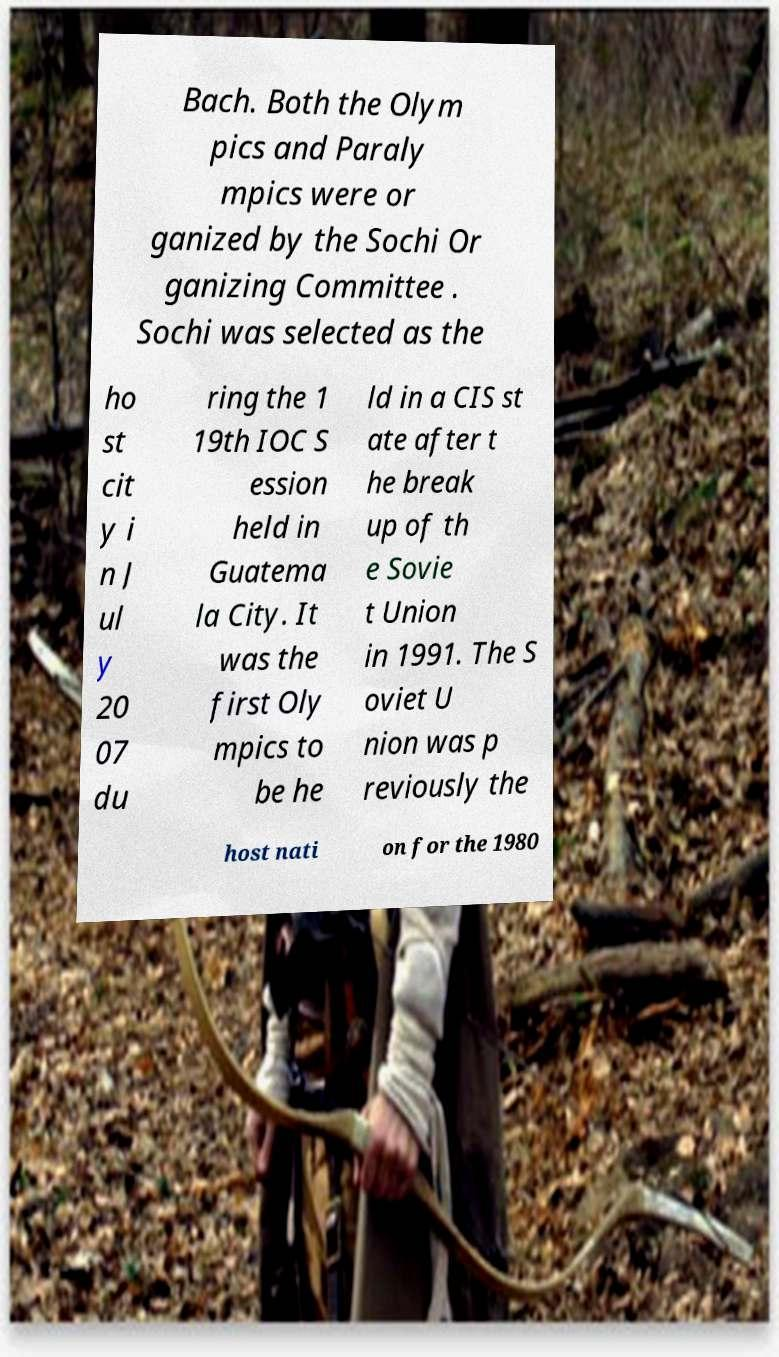Can you read and provide the text displayed in the image?This photo seems to have some interesting text. Can you extract and type it out for me? Bach. Both the Olym pics and Paraly mpics were or ganized by the Sochi Or ganizing Committee . Sochi was selected as the ho st cit y i n J ul y 20 07 du ring the 1 19th IOC S ession held in Guatema la City. It was the first Oly mpics to be he ld in a CIS st ate after t he break up of th e Sovie t Union in 1991. The S oviet U nion was p reviously the host nati on for the 1980 